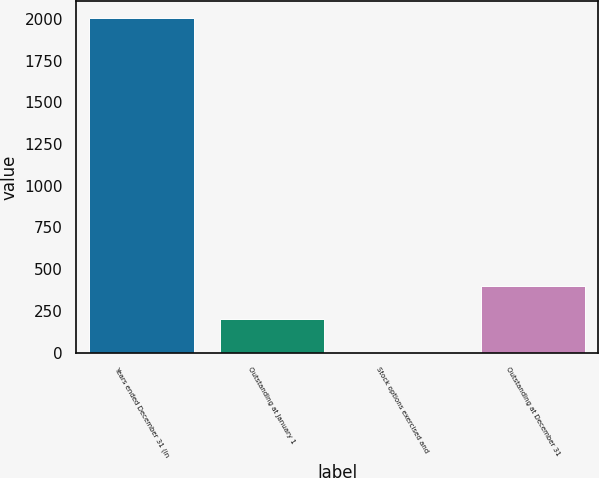Convert chart to OTSL. <chart><loc_0><loc_0><loc_500><loc_500><bar_chart><fcel>Years ended December 31 (in<fcel>Outstanding at January 1<fcel>Stock options exercised and<fcel>Outstanding at December 31<nl><fcel>2005<fcel>201.22<fcel>0.8<fcel>401.64<nl></chart> 